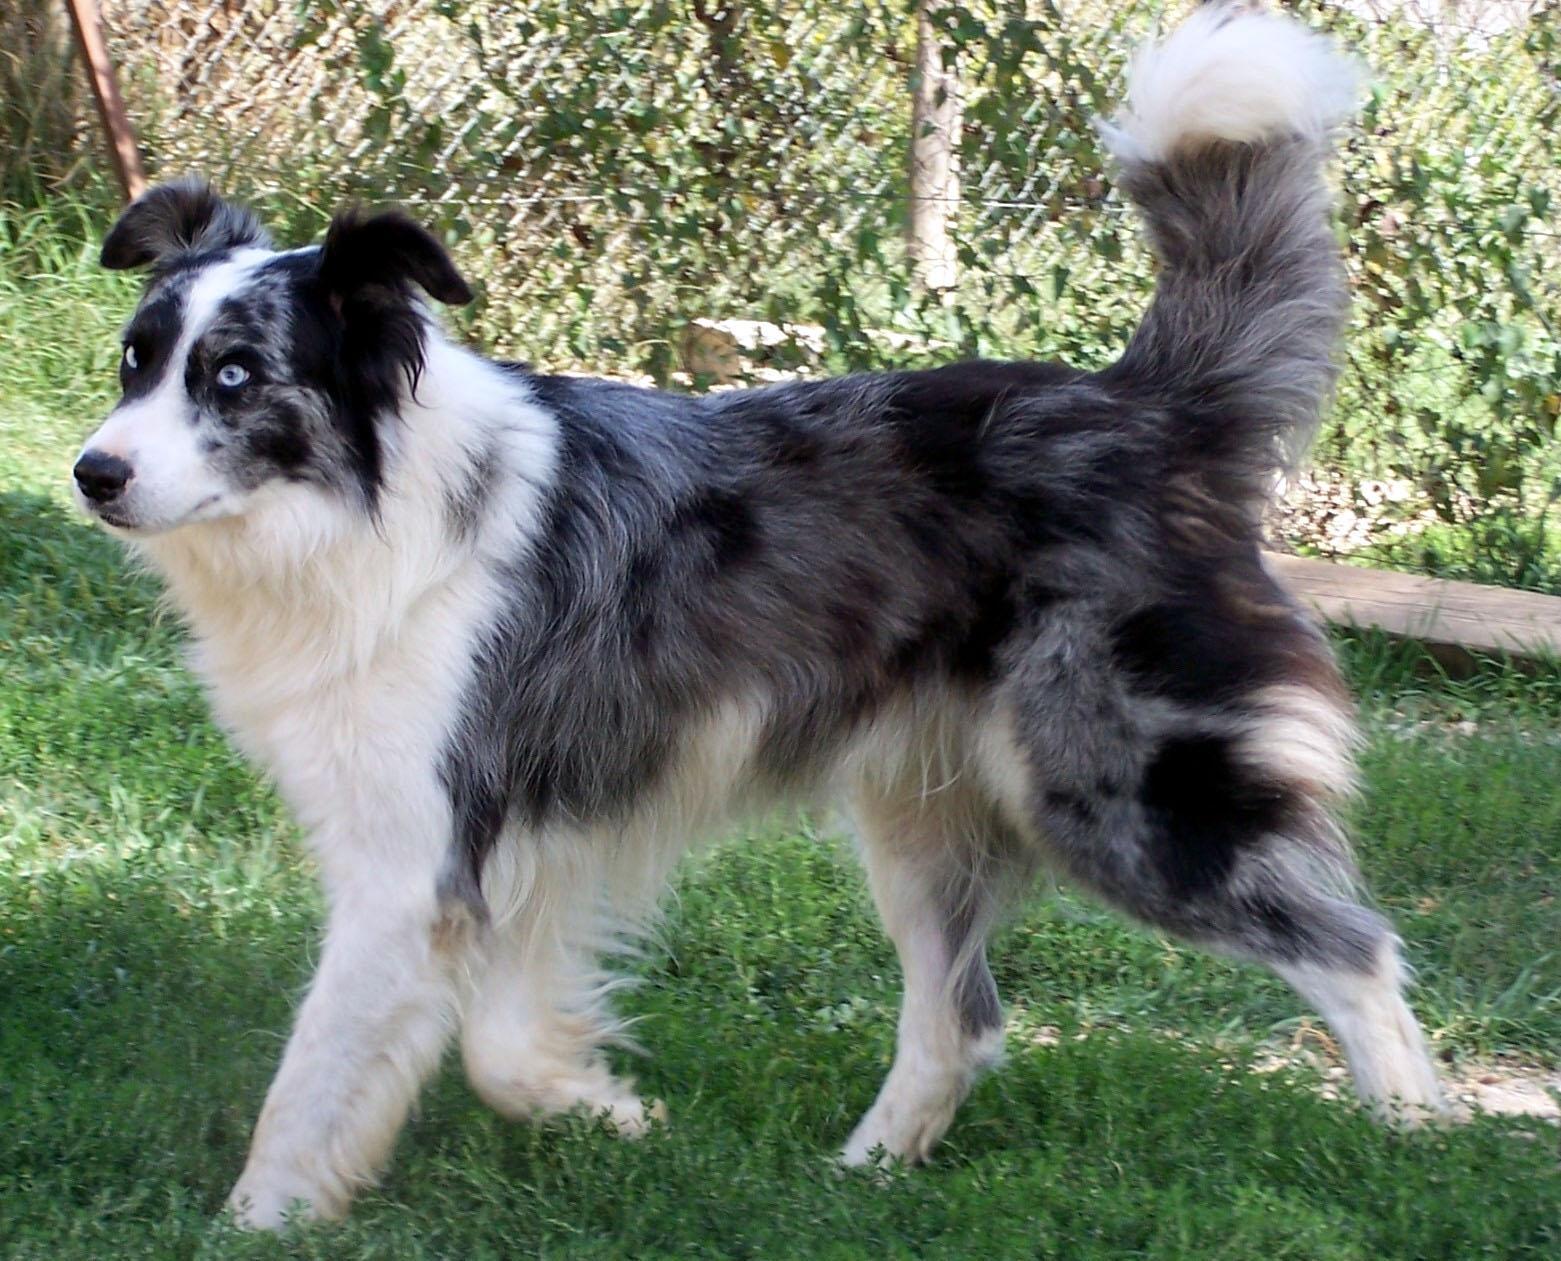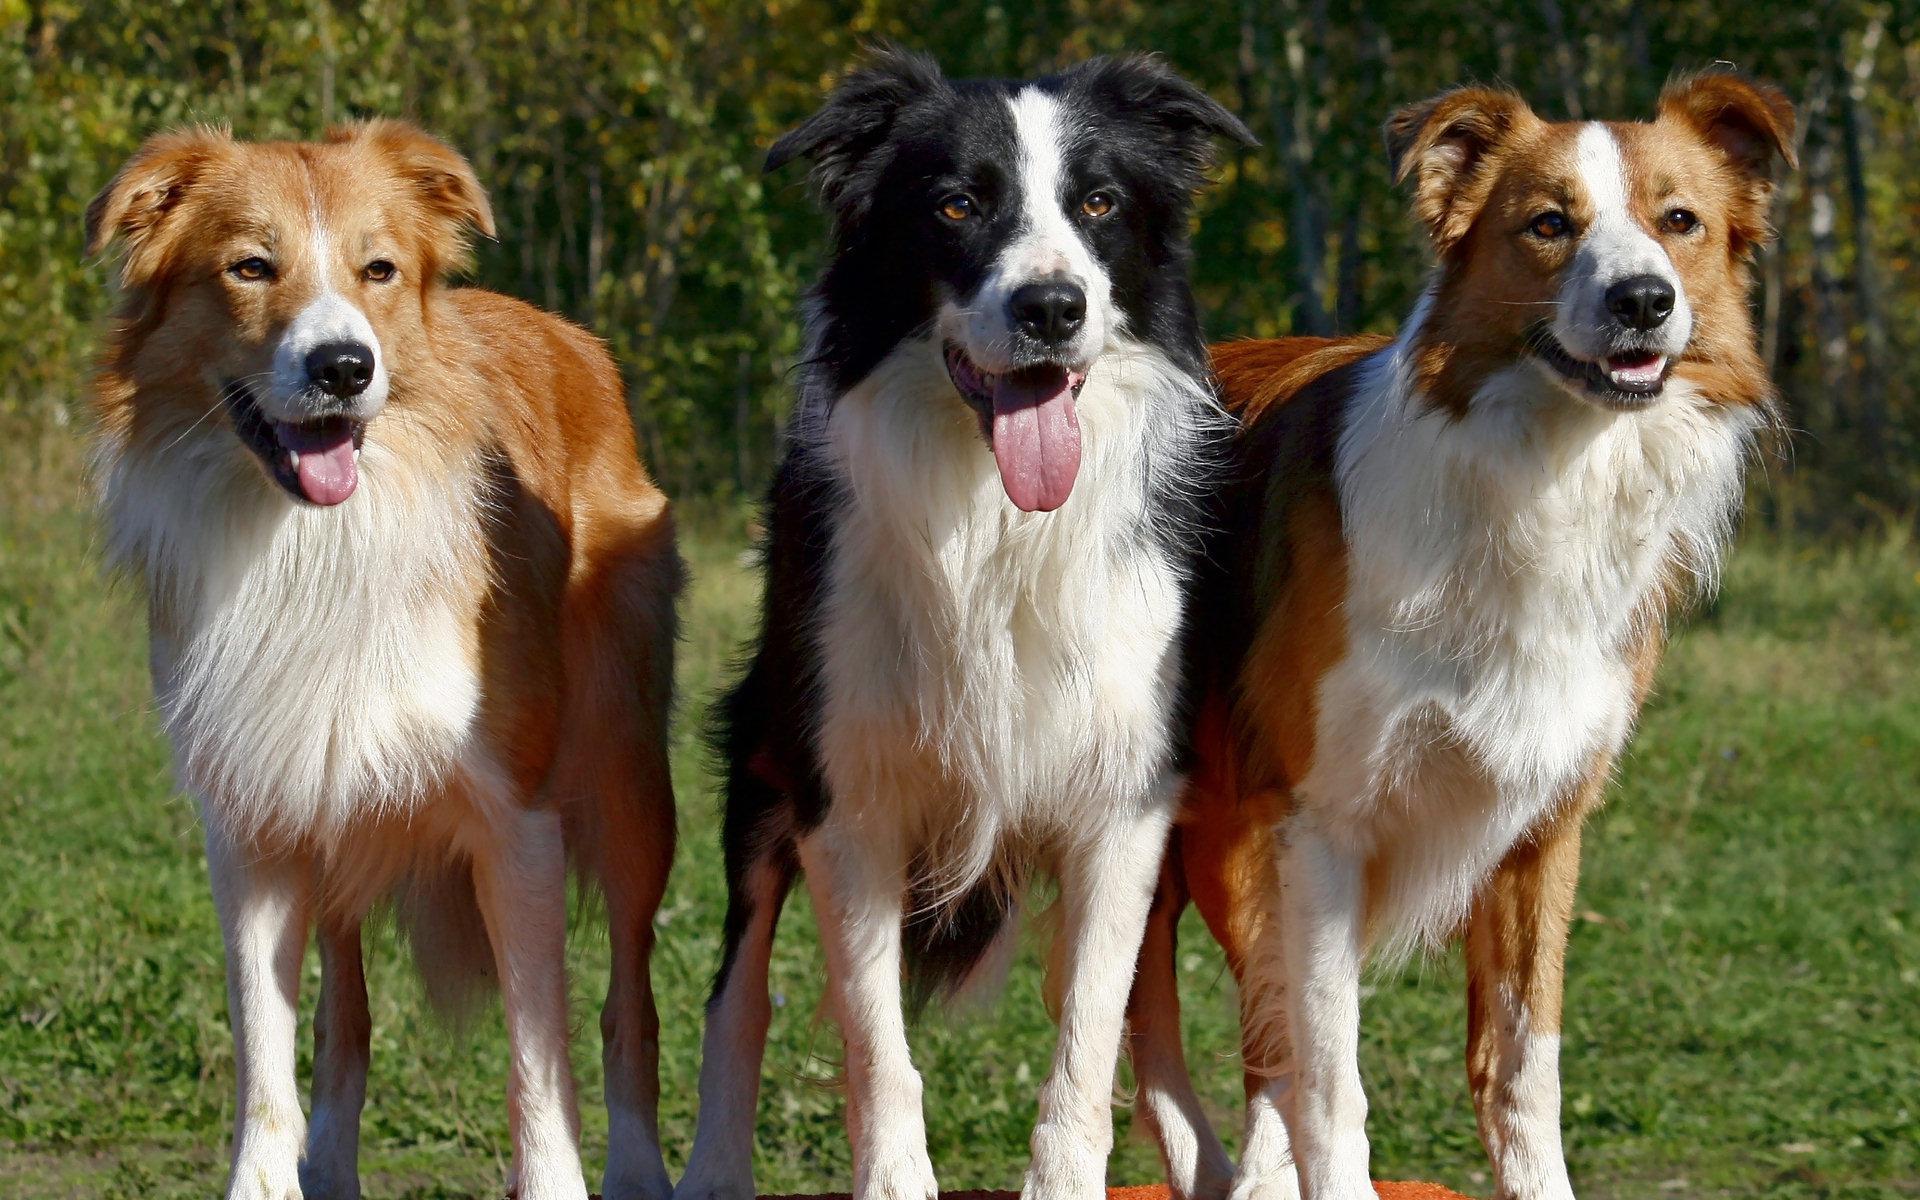The first image is the image on the left, the second image is the image on the right. Given the left and right images, does the statement "The dog in the image on the right is laying down with their face pointing forward." hold true? Answer yes or no. No. The first image is the image on the left, the second image is the image on the right. Analyze the images presented: Is the assertion "There are three dogs in one picture and one dog in the other picture." valid? Answer yes or no. Yes. 